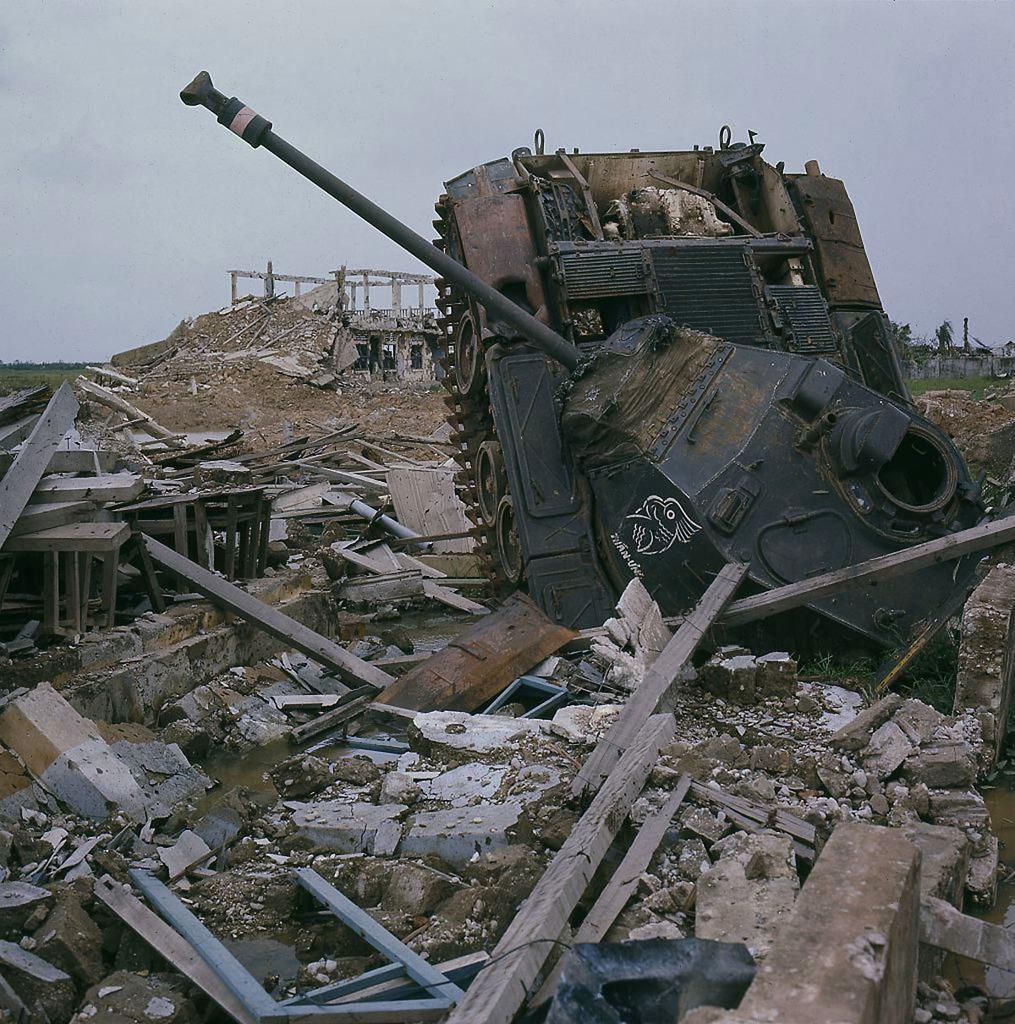What is the main subject of the image? The main subject of the image is an army tank. What else can be seen in the image besides the army tank? There is scrap visible in the image. What is visible in the background of the image? The sky is visible in the image. Can you describe the sky in the image? Clouds are present in the sky. What time of day is it in the image, based on the work being done by the fish? There are no fish present in the image, so it is not possible to determine the time of day based on their work. 